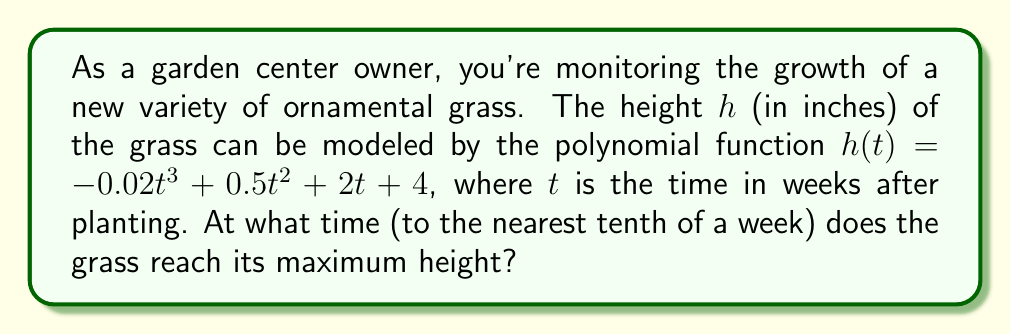Could you help me with this problem? To find the maximum height of the grass, we need to determine when the rate of change of the height function is zero. This occurs at the vertex of the polynomial function.

1) First, we need to find the derivative of $h(t)$:
   $$h'(t) = -0.06t^2 + t + 2$$

2) Set $h'(t) = 0$ and solve for $t$:
   $$-0.06t^2 + t + 2 = 0$$

3) This is a quadratic equation. We can solve it using the quadratic formula:
   $$t = \frac{-b \pm \sqrt{b^2 - 4ac}}{2a}$$
   where $a = -0.06$, $b = 1$, and $c = 2$

4) Plugging in these values:
   $$t = \frac{-1 \pm \sqrt{1^2 - 4(-0.06)(2)}}{2(-0.06)}$$
   $$= \frac{-1 \pm \sqrt{1 + 0.48}}{-0.12}$$
   $$= \frac{-1 \pm \sqrt{1.48}}{-0.12}$$
   $$= \frac{-1 \pm 1.2166}{-0.12}$$

5) This gives us two solutions:
   $$t_1 = \frac{-1 + 1.2166}{-0.12} \approx 1.8050$$
   $$t_2 = \frac{-1 - 1.2166}{-0.12} \approx 18.4717$$

6) Since we're dealing with plant growth, the positive solution (18.4717) is the one we're interested in.

7) Rounding to the nearest tenth of a week:
   18.4717 ≈ 18.5 weeks
Answer: 18.5 weeks 